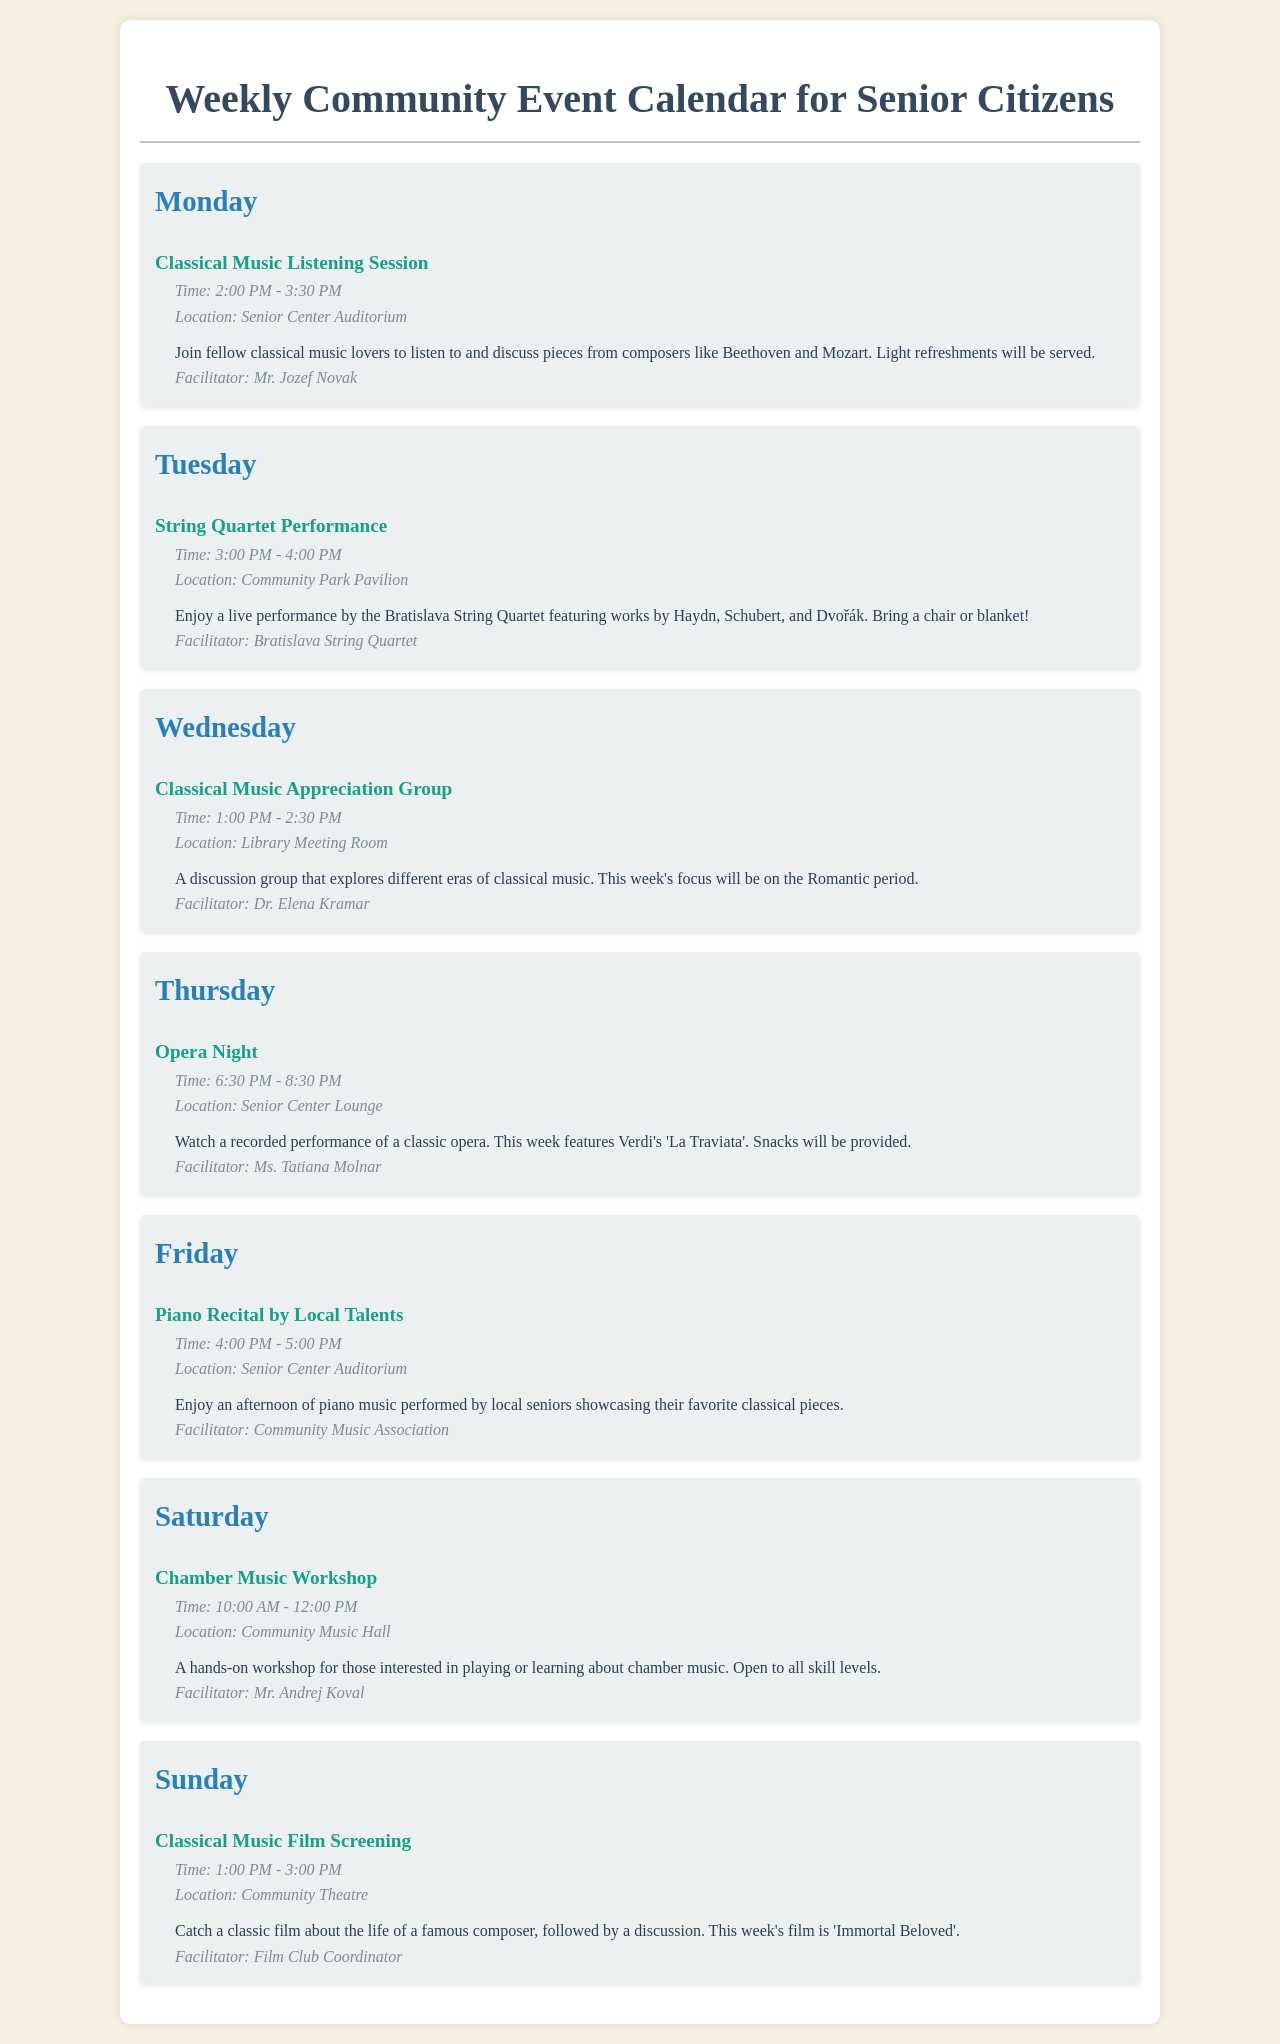What day is the Classical Music Listening Session? The Classical Music Listening Session is listed on Monday in the schedule.
Answer: Monday Who is facilitating the Classical Music Appreciation Group? The facilitator listed for the Classical Music Appreciation Group is Dr. Elena Kramar.
Answer: Dr. Elena Kramar What time does the String Quartet Performance start? The String Quartet Performance starts at 3:00 PM, as stated in the event details.
Answer: 3:00 PM How long does the Piano Recital last? The duration of the Piano Recital is indicated as one hour, from 4:00 PM to 5:00 PM.
Answer: 1 hour What is the location for the Opera Night? The location for the Opera Night is specified as the Senior Center Lounge in the document.
Answer: Senior Center Lounge How many classical music events are scheduled on Sunday? There is one classical music event scheduled on Sunday, which is the Classical Music Film Screening.
Answer: 1 What unique feature does the Chamber Music Workshop have? The Chamber Music Workshop is open to all skill levels, indicating inclusivity for participants.
Answer: All skill levels What is the theme of the discussion during the Classical Music Appreciation Group this week? The theme for the Classical Music Appreciation Group this week focuses on the Romantic period of classical music.
Answer: Romantic period What type of performance is featured on Tuesday? A live performance by the Bratislava String Quartet is featured on Tuesday.
Answer: String Quartet Performance 